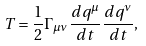Convert formula to latex. <formula><loc_0><loc_0><loc_500><loc_500>T = \frac { 1 } { 2 } \Gamma _ { \mu \nu } \frac { d q ^ { \mu } } { d t } \frac { d q ^ { \nu } } { d t } ,</formula> 